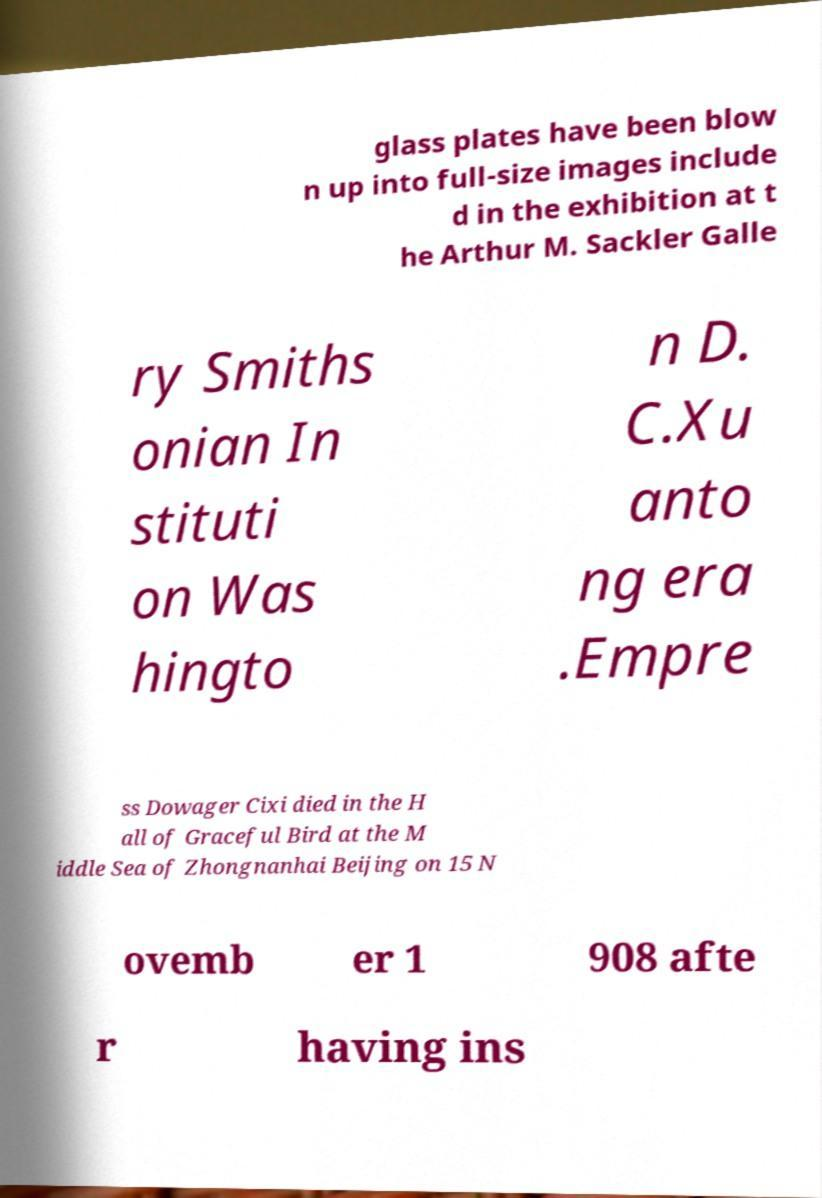For documentation purposes, I need the text within this image transcribed. Could you provide that? glass plates have been blow n up into full-size images include d in the exhibition at t he Arthur M. Sackler Galle ry Smiths onian In stituti on Was hingto n D. C.Xu anto ng era .Empre ss Dowager Cixi died in the H all of Graceful Bird at the M iddle Sea of Zhongnanhai Beijing on 15 N ovemb er 1 908 afte r having ins 